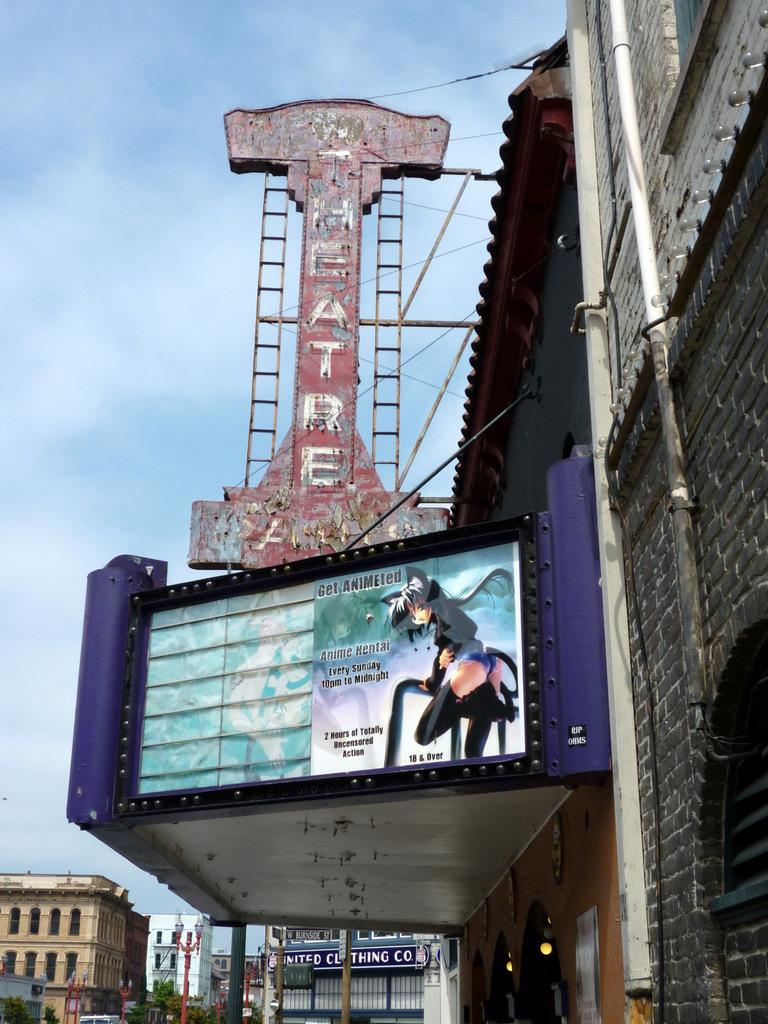<image>
Offer a succinct explanation of the picture presented. A very old theatre sign that shows Anime Hentai playing every sunday on the marque below. 